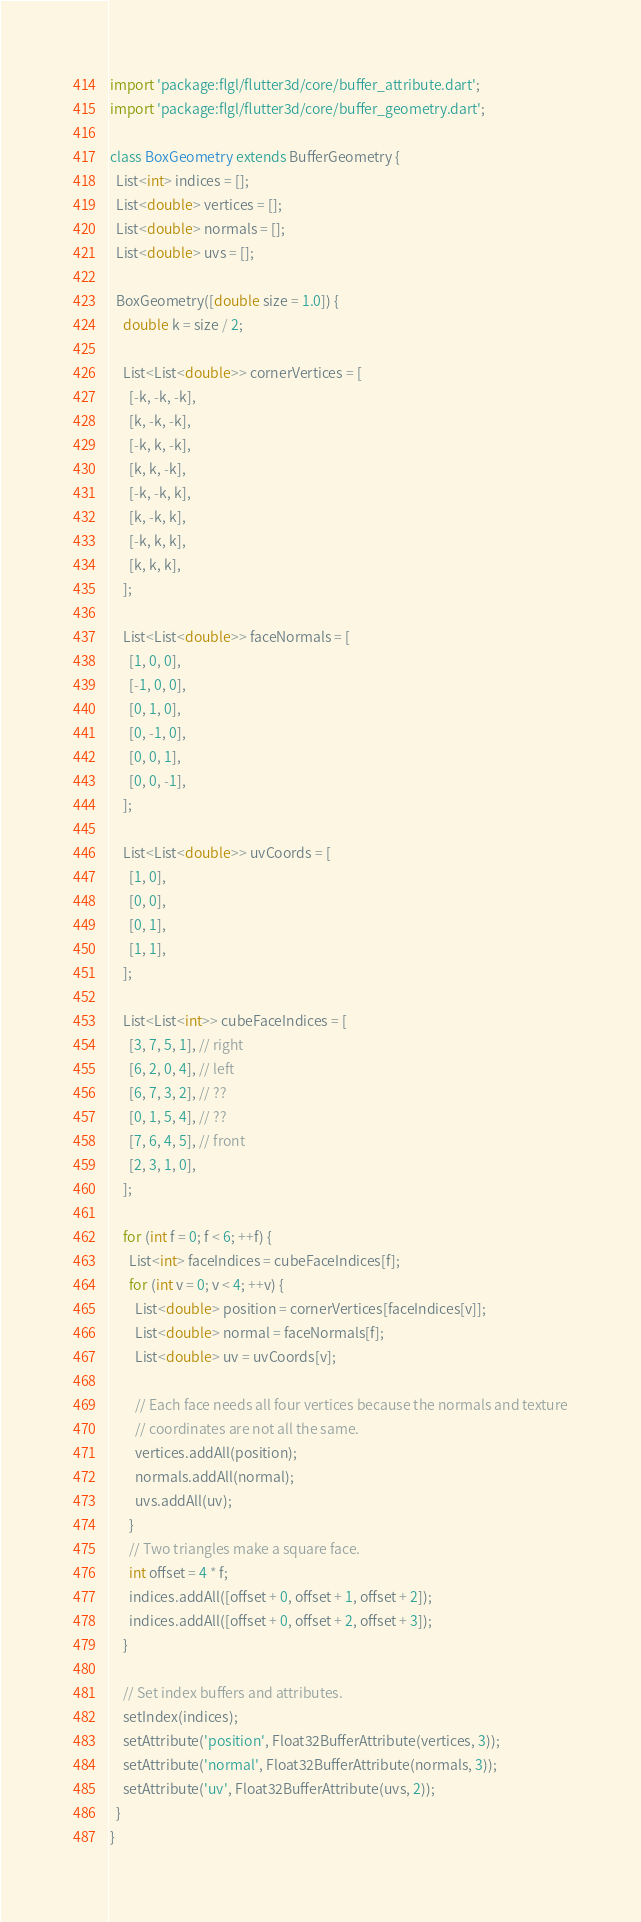Convert code to text. <code><loc_0><loc_0><loc_500><loc_500><_Dart_>import 'package:flgl/flutter3d/core/buffer_attribute.dart';
import 'package:flgl/flutter3d/core/buffer_geometry.dart';

class BoxGeometry extends BufferGeometry {
  List<int> indices = [];
  List<double> vertices = [];
  List<double> normals = [];
  List<double> uvs = [];

  BoxGeometry([double size = 1.0]) {
    double k = size / 2;

    List<List<double>> cornerVertices = [
      [-k, -k, -k],
      [k, -k, -k],
      [-k, k, -k],
      [k, k, -k],
      [-k, -k, k],
      [k, -k, k],
      [-k, k, k],
      [k, k, k],
    ];

    List<List<double>> faceNormals = [
      [1, 0, 0],
      [-1, 0, 0],
      [0, 1, 0],
      [0, -1, 0],
      [0, 0, 1],
      [0, 0, -1],
    ];

    List<List<double>> uvCoords = [
      [1, 0],
      [0, 0],
      [0, 1],
      [1, 1],
    ];

    List<List<int>> cubeFaceIndices = [
      [3, 7, 5, 1], // right
      [6, 2, 0, 4], // left
      [6, 7, 3, 2], // ??
      [0, 1, 5, 4], // ??
      [7, 6, 4, 5], // front
      [2, 3, 1, 0],
    ];

    for (int f = 0; f < 6; ++f) {
      List<int> faceIndices = cubeFaceIndices[f];
      for (int v = 0; v < 4; ++v) {
        List<double> position = cornerVertices[faceIndices[v]];
        List<double> normal = faceNormals[f];
        List<double> uv = uvCoords[v];

        // Each face needs all four vertices because the normals and texture
        // coordinates are not all the same.
        vertices.addAll(position);
        normals.addAll(normal);
        uvs.addAll(uv);
      }
      // Two triangles make a square face.
      int offset = 4 * f;
      indices.addAll([offset + 0, offset + 1, offset + 2]);
      indices.addAll([offset + 0, offset + 2, offset + 3]);
    }

    // Set index buffers and attributes.
    setIndex(indices);
    setAttribute('position', Float32BufferAttribute(vertices, 3));
    setAttribute('normal', Float32BufferAttribute(normals, 3));
    setAttribute('uv', Float32BufferAttribute(uvs, 2));
  }
}
</code> 